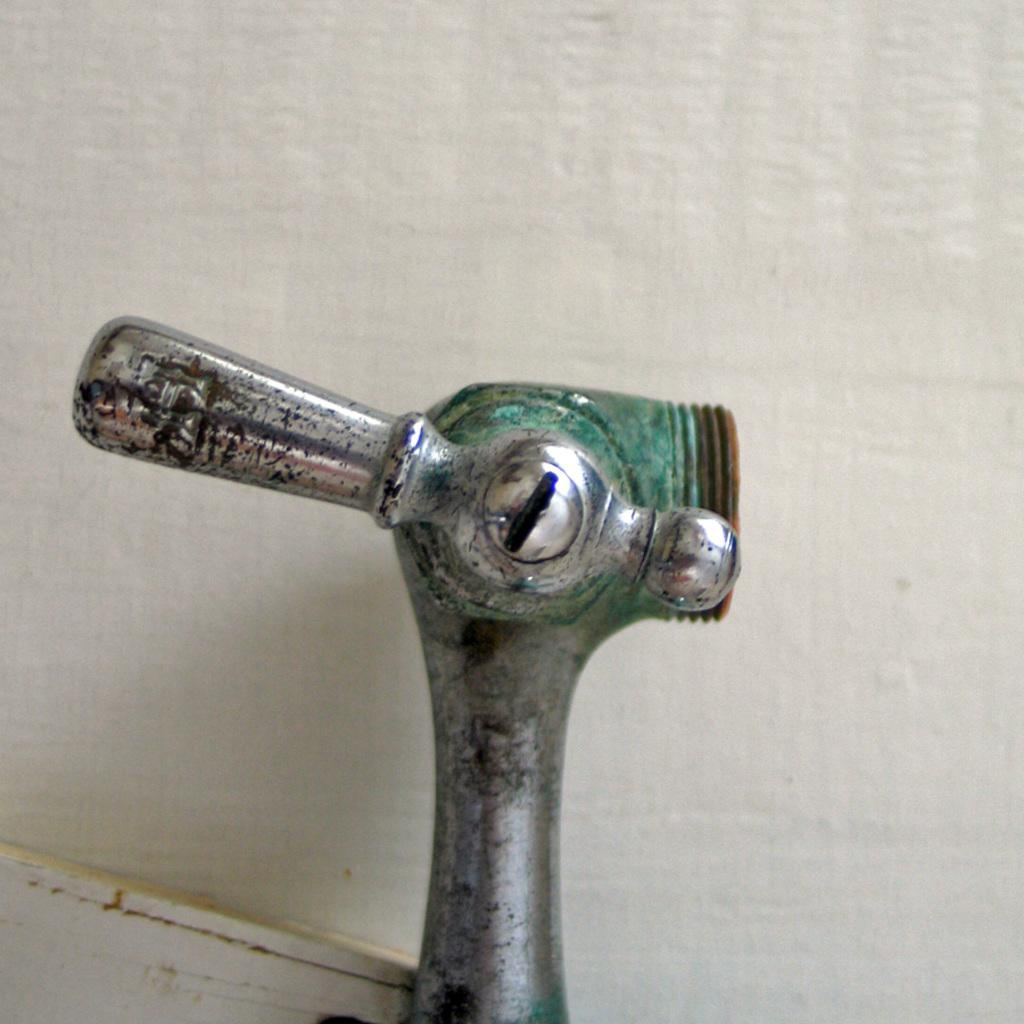What object is in the shape of a tap in the image? There is a steel rod in the shape of a tap in the image. What can be seen in the background of the image? There is a white wall in the background of the image. What type of celery is growing on the steel rod in the image? There is no celery present in the image; it features a steel rod in the shape of a tap and a white wall in the background. 